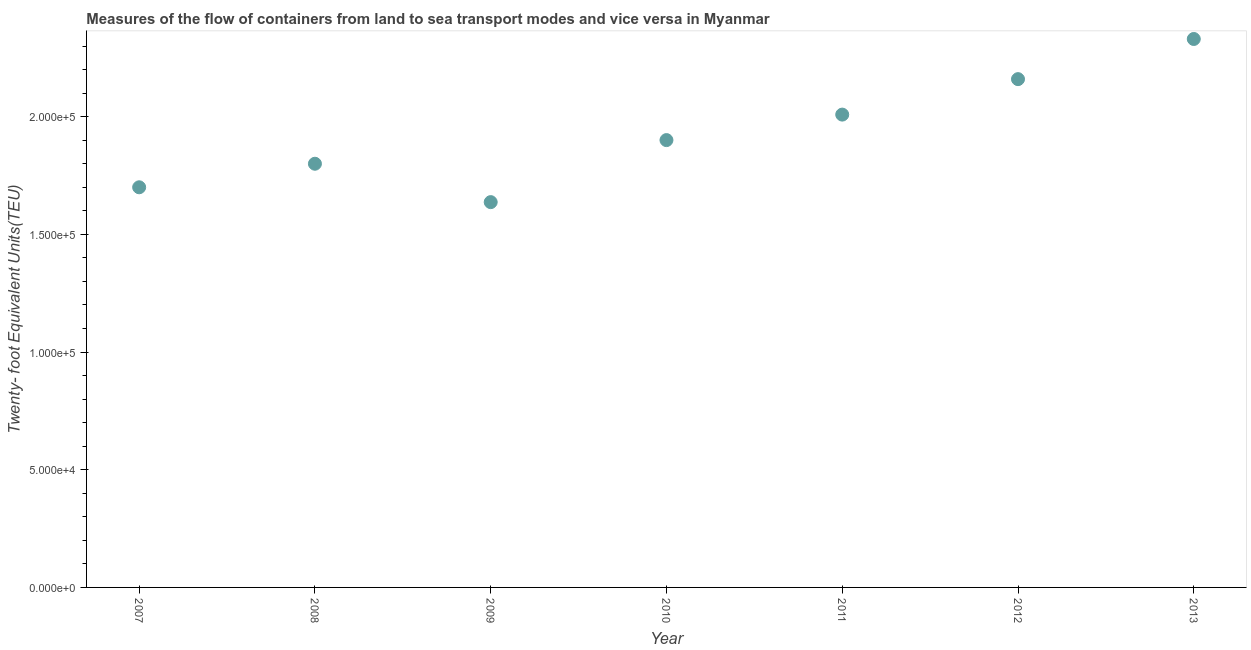What is the container port traffic in 2011?
Offer a terse response. 2.01e+05. Across all years, what is the maximum container port traffic?
Your answer should be very brief. 2.33e+05. Across all years, what is the minimum container port traffic?
Provide a succinct answer. 1.64e+05. What is the sum of the container port traffic?
Your answer should be compact. 1.35e+06. What is the difference between the container port traffic in 2010 and 2012?
Ensure brevity in your answer.  -2.59e+04. What is the average container port traffic per year?
Your answer should be compact. 1.93e+05. What is the median container port traffic?
Your answer should be very brief. 1.90e+05. In how many years, is the container port traffic greater than 160000 TEU?
Provide a short and direct response. 7. What is the ratio of the container port traffic in 2012 to that in 2013?
Ensure brevity in your answer.  0.93. Is the container port traffic in 2009 less than that in 2013?
Offer a terse response. Yes. Is the difference between the container port traffic in 2009 and 2013 greater than the difference between any two years?
Keep it short and to the point. Yes. What is the difference between the highest and the second highest container port traffic?
Your answer should be very brief. 1.71e+04. What is the difference between the highest and the lowest container port traffic?
Keep it short and to the point. 6.93e+04. In how many years, is the container port traffic greater than the average container port traffic taken over all years?
Offer a terse response. 3. How many dotlines are there?
Make the answer very short. 1. What is the difference between two consecutive major ticks on the Y-axis?
Give a very brief answer. 5.00e+04. Are the values on the major ticks of Y-axis written in scientific E-notation?
Make the answer very short. Yes. Does the graph contain grids?
Offer a terse response. No. What is the title of the graph?
Your response must be concise. Measures of the flow of containers from land to sea transport modes and vice versa in Myanmar. What is the label or title of the Y-axis?
Your answer should be compact. Twenty- foot Equivalent Units(TEU). What is the Twenty- foot Equivalent Units(TEU) in 2008?
Your response must be concise. 1.80e+05. What is the Twenty- foot Equivalent Units(TEU) in 2009?
Ensure brevity in your answer.  1.64e+05. What is the Twenty- foot Equivalent Units(TEU) in 2010?
Your answer should be very brief. 1.90e+05. What is the Twenty- foot Equivalent Units(TEU) in 2011?
Your response must be concise. 2.01e+05. What is the Twenty- foot Equivalent Units(TEU) in 2012?
Provide a succinct answer. 2.16e+05. What is the Twenty- foot Equivalent Units(TEU) in 2013?
Your answer should be compact. 2.33e+05. What is the difference between the Twenty- foot Equivalent Units(TEU) in 2007 and 2008?
Keep it short and to the point. -10000. What is the difference between the Twenty- foot Equivalent Units(TEU) in 2007 and 2009?
Offer a very short reply. 6308. What is the difference between the Twenty- foot Equivalent Units(TEU) in 2007 and 2010?
Your answer should be very brief. -2.00e+04. What is the difference between the Twenty- foot Equivalent Units(TEU) in 2007 and 2011?
Provide a succinct answer. -3.09e+04. What is the difference between the Twenty- foot Equivalent Units(TEU) in 2007 and 2012?
Your answer should be very brief. -4.59e+04. What is the difference between the Twenty- foot Equivalent Units(TEU) in 2007 and 2013?
Offer a very short reply. -6.30e+04. What is the difference between the Twenty- foot Equivalent Units(TEU) in 2008 and 2009?
Provide a short and direct response. 1.63e+04. What is the difference between the Twenty- foot Equivalent Units(TEU) in 2008 and 2010?
Your response must be concise. -1.00e+04. What is the difference between the Twenty- foot Equivalent Units(TEU) in 2008 and 2011?
Your response must be concise. -2.09e+04. What is the difference between the Twenty- foot Equivalent Units(TEU) in 2008 and 2012?
Give a very brief answer. -3.59e+04. What is the difference between the Twenty- foot Equivalent Units(TEU) in 2008 and 2013?
Offer a very short reply. -5.30e+04. What is the difference between the Twenty- foot Equivalent Units(TEU) in 2009 and 2010?
Ensure brevity in your answer.  -2.64e+04. What is the difference between the Twenty- foot Equivalent Units(TEU) in 2009 and 2011?
Make the answer very short. -3.72e+04. What is the difference between the Twenty- foot Equivalent Units(TEU) in 2009 and 2012?
Give a very brief answer. -5.23e+04. What is the difference between the Twenty- foot Equivalent Units(TEU) in 2009 and 2013?
Offer a terse response. -6.93e+04. What is the difference between the Twenty- foot Equivalent Units(TEU) in 2010 and 2011?
Make the answer very short. -1.08e+04. What is the difference between the Twenty- foot Equivalent Units(TEU) in 2010 and 2012?
Offer a very short reply. -2.59e+04. What is the difference between the Twenty- foot Equivalent Units(TEU) in 2010 and 2013?
Keep it short and to the point. -4.30e+04. What is the difference between the Twenty- foot Equivalent Units(TEU) in 2011 and 2012?
Give a very brief answer. -1.51e+04. What is the difference between the Twenty- foot Equivalent Units(TEU) in 2011 and 2013?
Provide a succinct answer. -3.21e+04. What is the difference between the Twenty- foot Equivalent Units(TEU) in 2012 and 2013?
Provide a succinct answer. -1.71e+04. What is the ratio of the Twenty- foot Equivalent Units(TEU) in 2007 to that in 2008?
Provide a succinct answer. 0.94. What is the ratio of the Twenty- foot Equivalent Units(TEU) in 2007 to that in 2009?
Offer a terse response. 1.04. What is the ratio of the Twenty- foot Equivalent Units(TEU) in 2007 to that in 2010?
Your response must be concise. 0.9. What is the ratio of the Twenty- foot Equivalent Units(TEU) in 2007 to that in 2011?
Ensure brevity in your answer.  0.85. What is the ratio of the Twenty- foot Equivalent Units(TEU) in 2007 to that in 2012?
Offer a terse response. 0.79. What is the ratio of the Twenty- foot Equivalent Units(TEU) in 2007 to that in 2013?
Provide a short and direct response. 0.73. What is the ratio of the Twenty- foot Equivalent Units(TEU) in 2008 to that in 2010?
Give a very brief answer. 0.95. What is the ratio of the Twenty- foot Equivalent Units(TEU) in 2008 to that in 2011?
Keep it short and to the point. 0.9. What is the ratio of the Twenty- foot Equivalent Units(TEU) in 2008 to that in 2012?
Keep it short and to the point. 0.83. What is the ratio of the Twenty- foot Equivalent Units(TEU) in 2008 to that in 2013?
Ensure brevity in your answer.  0.77. What is the ratio of the Twenty- foot Equivalent Units(TEU) in 2009 to that in 2010?
Keep it short and to the point. 0.86. What is the ratio of the Twenty- foot Equivalent Units(TEU) in 2009 to that in 2011?
Your answer should be very brief. 0.81. What is the ratio of the Twenty- foot Equivalent Units(TEU) in 2009 to that in 2012?
Provide a succinct answer. 0.76. What is the ratio of the Twenty- foot Equivalent Units(TEU) in 2009 to that in 2013?
Offer a terse response. 0.7. What is the ratio of the Twenty- foot Equivalent Units(TEU) in 2010 to that in 2011?
Offer a very short reply. 0.95. What is the ratio of the Twenty- foot Equivalent Units(TEU) in 2010 to that in 2012?
Provide a succinct answer. 0.88. What is the ratio of the Twenty- foot Equivalent Units(TEU) in 2010 to that in 2013?
Make the answer very short. 0.82. What is the ratio of the Twenty- foot Equivalent Units(TEU) in 2011 to that in 2013?
Your answer should be compact. 0.86. What is the ratio of the Twenty- foot Equivalent Units(TEU) in 2012 to that in 2013?
Offer a very short reply. 0.93. 